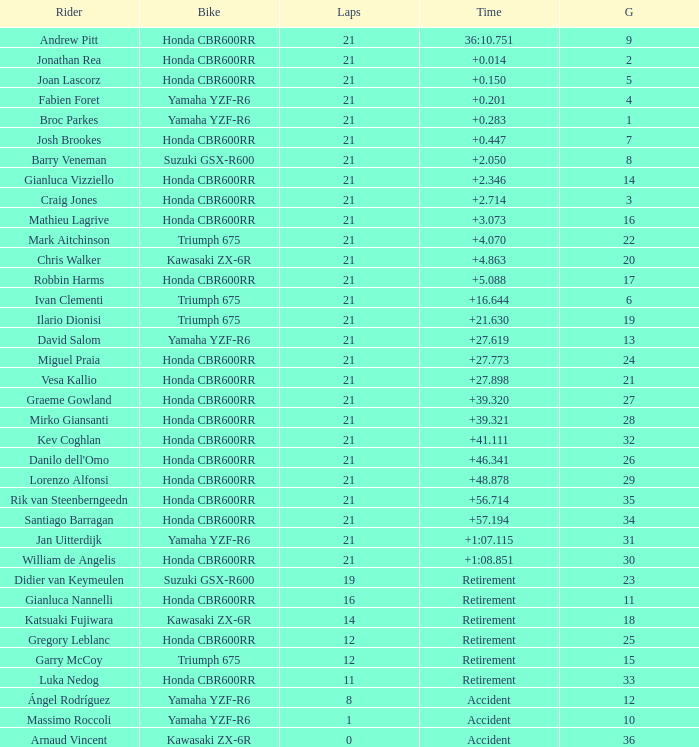Which driver secured the top grid position with a time difference of +0.283? 1.0. 